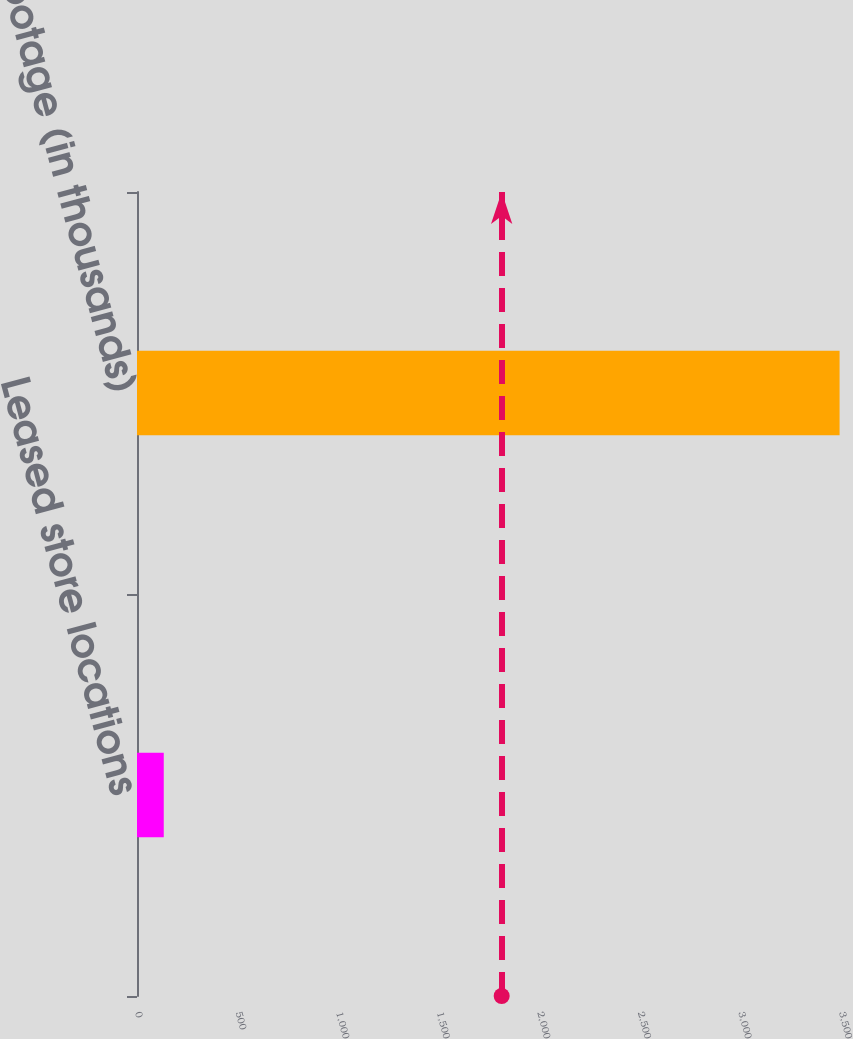Convert chart to OTSL. <chart><loc_0><loc_0><loc_500><loc_500><bar_chart><fcel>Leased store locations<fcel>Square footage (in thousands)<nl><fcel>133<fcel>3493<nl></chart> 